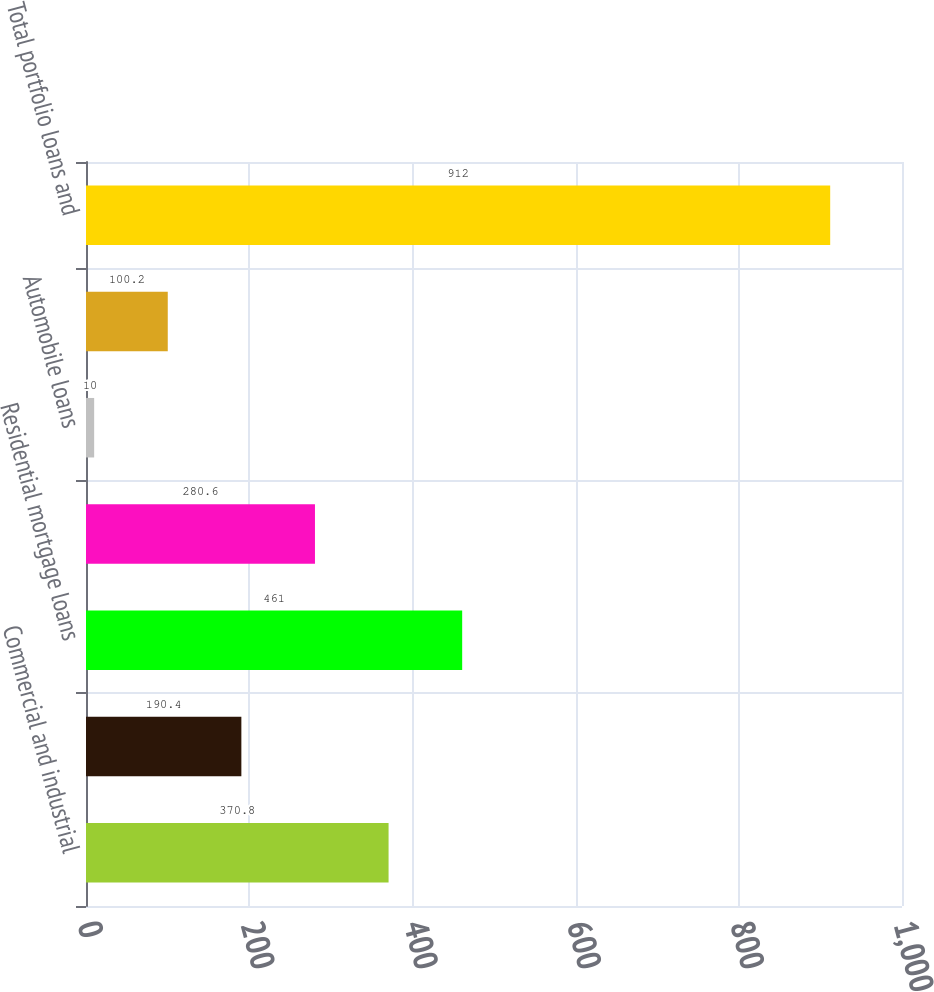Convert chart. <chart><loc_0><loc_0><loc_500><loc_500><bar_chart><fcel>Commercial and industrial<fcel>Commercial mortgage<fcel>Residential mortgage loans<fcel>Home equity<fcel>Automobile loans<fcel>Credit card<fcel>Total portfolio loans and<nl><fcel>370.8<fcel>190.4<fcel>461<fcel>280.6<fcel>10<fcel>100.2<fcel>912<nl></chart> 